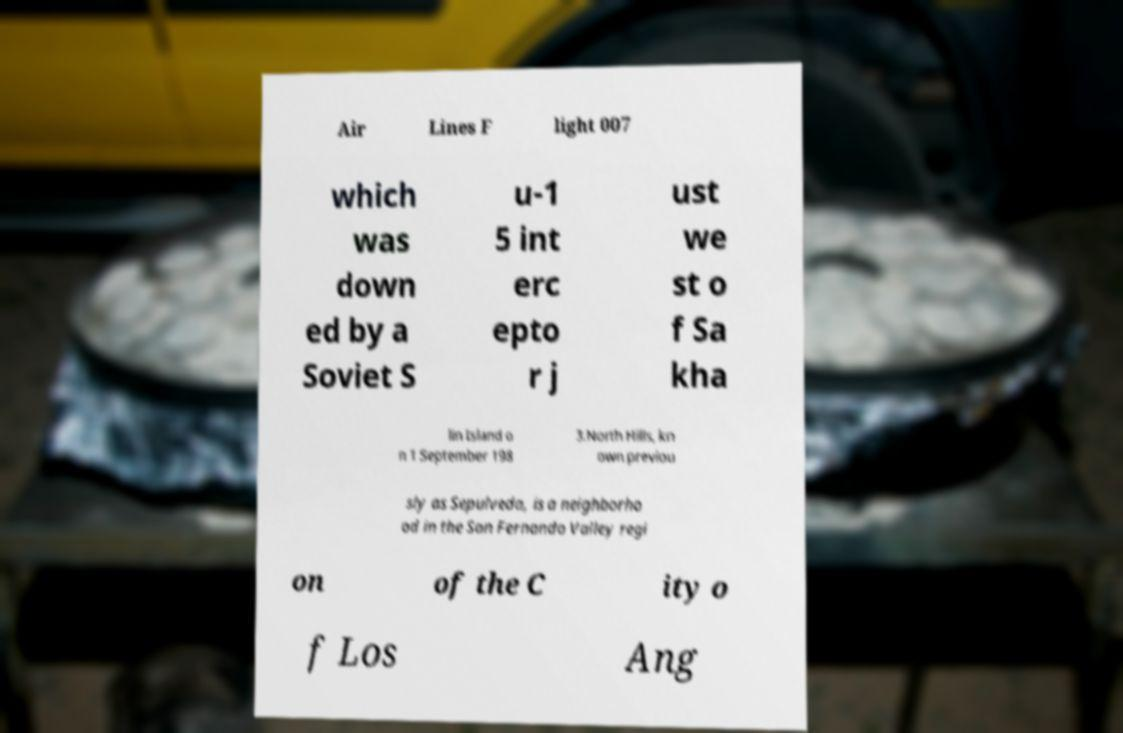Can you accurately transcribe the text from the provided image for me? Air Lines F light 007 which was down ed by a Soviet S u-1 5 int erc epto r j ust we st o f Sa kha lin Island o n 1 September 198 3.North Hills, kn own previou sly as Sepulveda, is a neighborho od in the San Fernando Valley regi on of the C ity o f Los Ang 